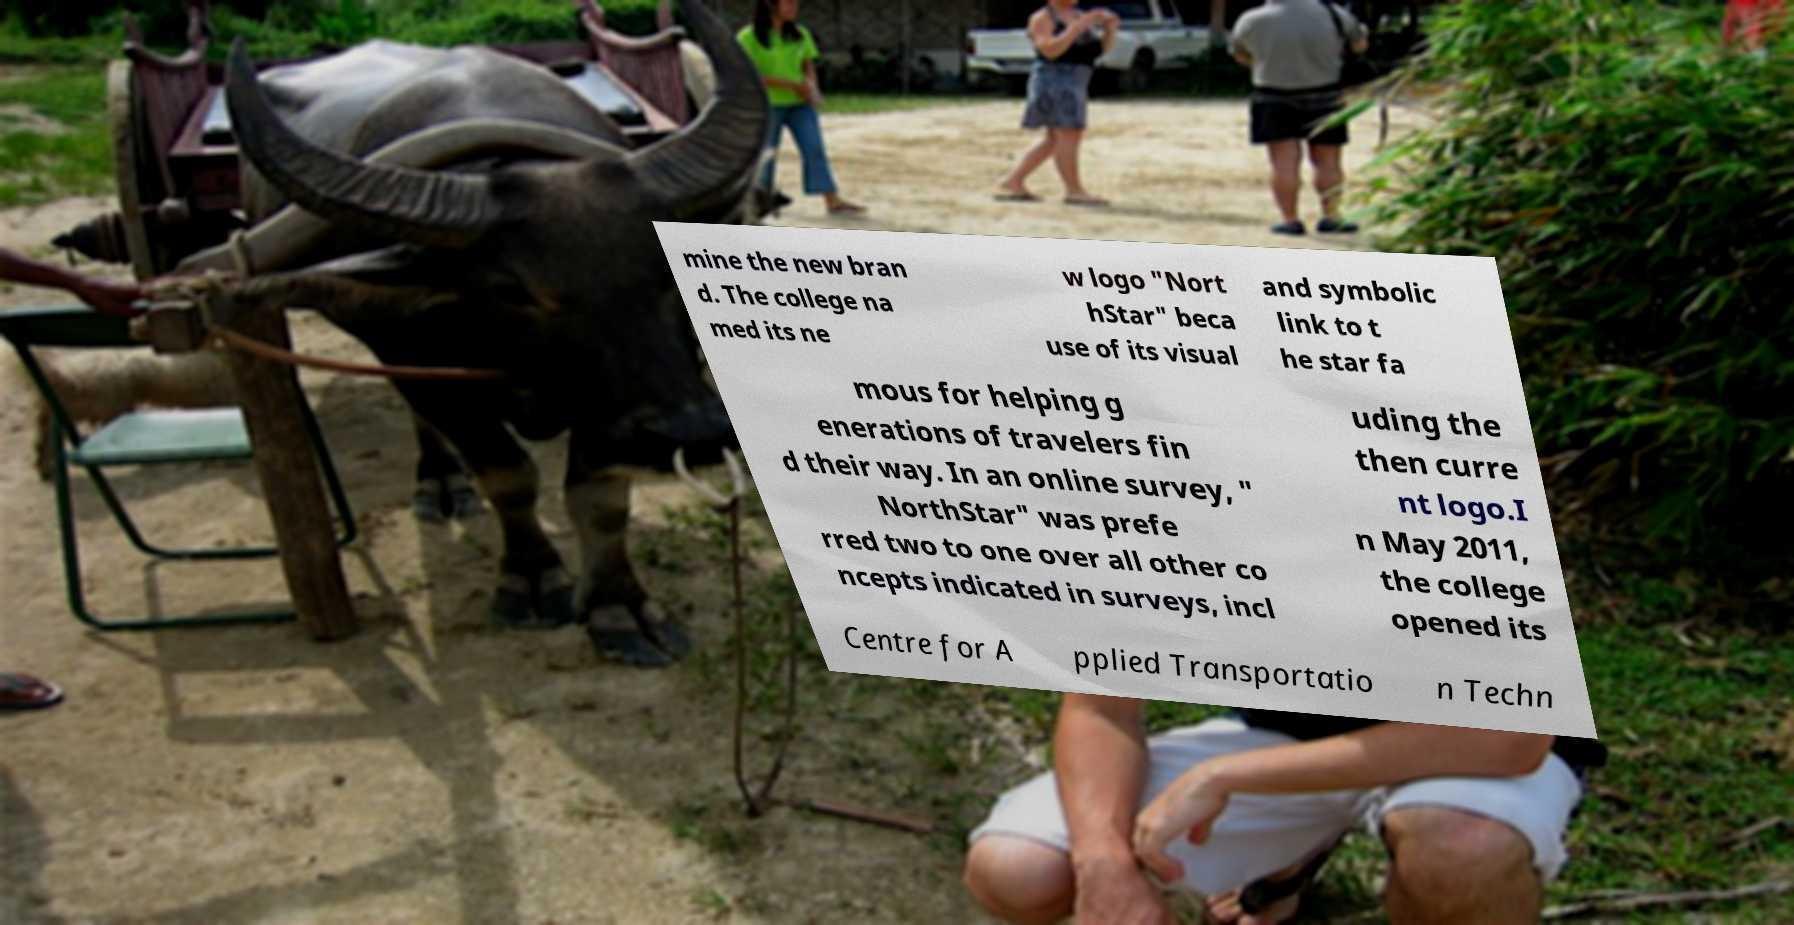There's text embedded in this image that I need extracted. Can you transcribe it verbatim? mine the new bran d. The college na med its ne w logo "Nort hStar" beca use of its visual and symbolic link to t he star fa mous for helping g enerations of travelers fin d their way. In an online survey, " NorthStar" was prefe rred two to one over all other co ncepts indicated in surveys, incl uding the then curre nt logo.I n May 2011, the college opened its Centre for A pplied Transportatio n Techn 